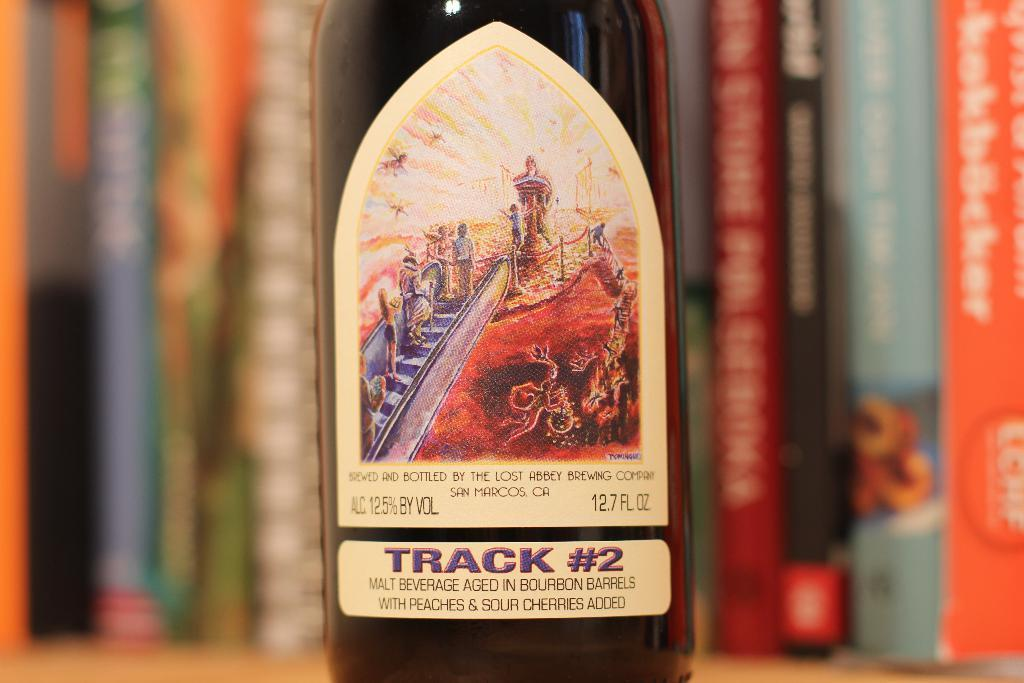<image>
Write a terse but informative summary of the picture. A bottle is marked as having been brewed at the Lost Abbey Brewing Company. 